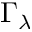<formula> <loc_0><loc_0><loc_500><loc_500>\Gamma _ { \lambda }</formula> 